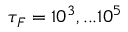<formula> <loc_0><loc_0><loc_500><loc_500>\tau _ { F } = 1 0 ^ { 3 } , \dots 1 0 ^ { 5 }</formula> 